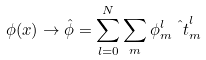<formula> <loc_0><loc_0><loc_500><loc_500>\phi ( x ) \to \hat { \phi } = \sum _ { l = 0 } ^ { N } \sum _ { m } \phi ^ { l } _ { m } \hat { \ t } ^ { l } _ { m }</formula> 